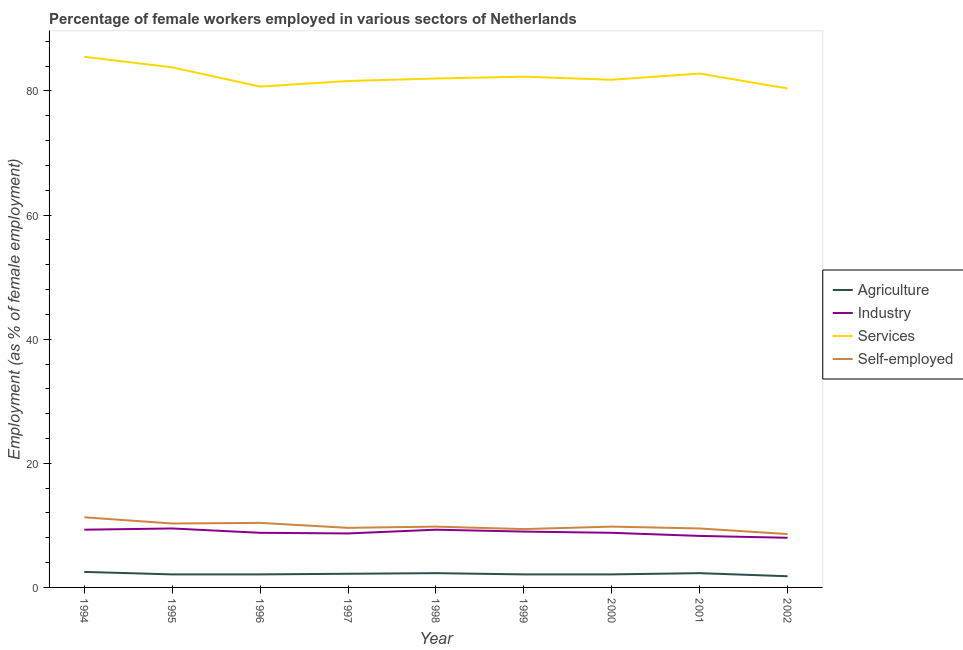How many different coloured lines are there?
Provide a succinct answer. 4. Does the line corresponding to percentage of self employed female workers intersect with the line corresponding to percentage of female workers in industry?
Keep it short and to the point. No. Is the number of lines equal to the number of legend labels?
Keep it short and to the point. Yes. What is the percentage of self employed female workers in 1994?
Your answer should be compact. 11.3. Across all years, what is the maximum percentage of female workers in services?
Make the answer very short. 85.5. Across all years, what is the minimum percentage of female workers in industry?
Ensure brevity in your answer.  8. In which year was the percentage of self employed female workers minimum?
Keep it short and to the point. 2002. What is the total percentage of female workers in agriculture in the graph?
Your answer should be compact. 19.5. What is the difference between the percentage of female workers in industry in 1996 and that in 1999?
Make the answer very short. -0.2. What is the difference between the percentage of self employed female workers in 2000 and the percentage of female workers in industry in 1995?
Give a very brief answer. 0.3. What is the average percentage of female workers in services per year?
Offer a terse response. 82.32. In the year 1996, what is the difference between the percentage of female workers in services and percentage of self employed female workers?
Provide a succinct answer. 70.3. In how many years, is the percentage of female workers in services greater than 64 %?
Provide a succinct answer. 9. What is the ratio of the percentage of female workers in services in 1998 to that in 2002?
Keep it short and to the point. 1.02. What is the difference between the highest and the second highest percentage of female workers in agriculture?
Your answer should be very brief. 0.2. What is the difference between the highest and the lowest percentage of female workers in services?
Your answer should be compact. 5.1. Is it the case that in every year, the sum of the percentage of self employed female workers and percentage of female workers in services is greater than the sum of percentage of female workers in agriculture and percentage of female workers in industry?
Your answer should be compact. Yes. How many years are there in the graph?
Make the answer very short. 9. What is the difference between two consecutive major ticks on the Y-axis?
Offer a terse response. 20. Are the values on the major ticks of Y-axis written in scientific E-notation?
Your response must be concise. No. Does the graph contain any zero values?
Ensure brevity in your answer.  No. Does the graph contain grids?
Your answer should be compact. No. Where does the legend appear in the graph?
Provide a succinct answer. Center right. How many legend labels are there?
Ensure brevity in your answer.  4. What is the title of the graph?
Give a very brief answer. Percentage of female workers employed in various sectors of Netherlands. What is the label or title of the X-axis?
Provide a succinct answer. Year. What is the label or title of the Y-axis?
Your answer should be compact. Employment (as % of female employment). What is the Employment (as % of female employment) of Agriculture in 1994?
Provide a short and direct response. 2.5. What is the Employment (as % of female employment) of Industry in 1994?
Your response must be concise. 9.3. What is the Employment (as % of female employment) of Services in 1994?
Offer a very short reply. 85.5. What is the Employment (as % of female employment) of Self-employed in 1994?
Provide a succinct answer. 11.3. What is the Employment (as % of female employment) of Agriculture in 1995?
Keep it short and to the point. 2.1. What is the Employment (as % of female employment) of Services in 1995?
Offer a very short reply. 83.8. What is the Employment (as % of female employment) of Self-employed in 1995?
Ensure brevity in your answer.  10.3. What is the Employment (as % of female employment) in Agriculture in 1996?
Offer a very short reply. 2.1. What is the Employment (as % of female employment) in Industry in 1996?
Offer a very short reply. 8.8. What is the Employment (as % of female employment) in Services in 1996?
Give a very brief answer. 80.7. What is the Employment (as % of female employment) in Self-employed in 1996?
Keep it short and to the point. 10.4. What is the Employment (as % of female employment) in Agriculture in 1997?
Keep it short and to the point. 2.2. What is the Employment (as % of female employment) of Industry in 1997?
Your answer should be compact. 8.7. What is the Employment (as % of female employment) in Services in 1997?
Provide a short and direct response. 81.6. What is the Employment (as % of female employment) in Self-employed in 1997?
Your response must be concise. 9.6. What is the Employment (as % of female employment) of Agriculture in 1998?
Offer a terse response. 2.3. What is the Employment (as % of female employment) in Industry in 1998?
Provide a short and direct response. 9.3. What is the Employment (as % of female employment) of Services in 1998?
Your answer should be very brief. 82. What is the Employment (as % of female employment) in Self-employed in 1998?
Offer a very short reply. 9.8. What is the Employment (as % of female employment) in Agriculture in 1999?
Make the answer very short. 2.1. What is the Employment (as % of female employment) of Services in 1999?
Make the answer very short. 82.3. What is the Employment (as % of female employment) in Self-employed in 1999?
Your answer should be compact. 9.4. What is the Employment (as % of female employment) in Agriculture in 2000?
Your response must be concise. 2.1. What is the Employment (as % of female employment) in Industry in 2000?
Provide a short and direct response. 8.8. What is the Employment (as % of female employment) in Services in 2000?
Give a very brief answer. 81.8. What is the Employment (as % of female employment) of Self-employed in 2000?
Provide a short and direct response. 9.8. What is the Employment (as % of female employment) in Agriculture in 2001?
Offer a very short reply. 2.3. What is the Employment (as % of female employment) in Industry in 2001?
Give a very brief answer. 8.3. What is the Employment (as % of female employment) of Services in 2001?
Make the answer very short. 82.8. What is the Employment (as % of female employment) in Self-employed in 2001?
Provide a succinct answer. 9.5. What is the Employment (as % of female employment) in Agriculture in 2002?
Ensure brevity in your answer.  1.8. What is the Employment (as % of female employment) in Industry in 2002?
Provide a short and direct response. 8. What is the Employment (as % of female employment) in Services in 2002?
Offer a terse response. 80.4. What is the Employment (as % of female employment) of Self-employed in 2002?
Provide a short and direct response. 8.6. Across all years, what is the maximum Employment (as % of female employment) in Industry?
Keep it short and to the point. 9.5. Across all years, what is the maximum Employment (as % of female employment) of Services?
Your answer should be compact. 85.5. Across all years, what is the maximum Employment (as % of female employment) in Self-employed?
Provide a short and direct response. 11.3. Across all years, what is the minimum Employment (as % of female employment) of Agriculture?
Make the answer very short. 1.8. Across all years, what is the minimum Employment (as % of female employment) of Services?
Your response must be concise. 80.4. Across all years, what is the minimum Employment (as % of female employment) in Self-employed?
Make the answer very short. 8.6. What is the total Employment (as % of female employment) in Industry in the graph?
Provide a short and direct response. 79.7. What is the total Employment (as % of female employment) of Services in the graph?
Keep it short and to the point. 740.9. What is the total Employment (as % of female employment) in Self-employed in the graph?
Your answer should be compact. 88.7. What is the difference between the Employment (as % of female employment) in Industry in 1994 and that in 1995?
Give a very brief answer. -0.2. What is the difference between the Employment (as % of female employment) of Services in 1994 and that in 1995?
Offer a very short reply. 1.7. What is the difference between the Employment (as % of female employment) of Services in 1994 and that in 1996?
Your answer should be very brief. 4.8. What is the difference between the Employment (as % of female employment) in Agriculture in 1994 and that in 1997?
Your answer should be compact. 0.3. What is the difference between the Employment (as % of female employment) in Industry in 1994 and that in 1997?
Your response must be concise. 0.6. What is the difference between the Employment (as % of female employment) of Self-employed in 1994 and that in 1997?
Provide a short and direct response. 1.7. What is the difference between the Employment (as % of female employment) of Industry in 1994 and that in 1998?
Offer a very short reply. 0. What is the difference between the Employment (as % of female employment) of Agriculture in 1994 and that in 1999?
Provide a short and direct response. 0.4. What is the difference between the Employment (as % of female employment) of Services in 1994 and that in 1999?
Offer a very short reply. 3.2. What is the difference between the Employment (as % of female employment) in Industry in 1994 and that in 2000?
Your response must be concise. 0.5. What is the difference between the Employment (as % of female employment) in Services in 1994 and that in 2000?
Your answer should be very brief. 3.7. What is the difference between the Employment (as % of female employment) of Agriculture in 1994 and that in 2001?
Keep it short and to the point. 0.2. What is the difference between the Employment (as % of female employment) in Services in 1994 and that in 2001?
Ensure brevity in your answer.  2.7. What is the difference between the Employment (as % of female employment) of Self-employed in 1994 and that in 2001?
Provide a short and direct response. 1.8. What is the difference between the Employment (as % of female employment) of Industry in 1994 and that in 2002?
Offer a terse response. 1.3. What is the difference between the Employment (as % of female employment) in Industry in 1995 and that in 1996?
Give a very brief answer. 0.7. What is the difference between the Employment (as % of female employment) in Industry in 1995 and that in 1997?
Make the answer very short. 0.8. What is the difference between the Employment (as % of female employment) in Services in 1995 and that in 1997?
Provide a short and direct response. 2.2. What is the difference between the Employment (as % of female employment) of Industry in 1995 and that in 1998?
Provide a succinct answer. 0.2. What is the difference between the Employment (as % of female employment) of Services in 1995 and that in 1998?
Keep it short and to the point. 1.8. What is the difference between the Employment (as % of female employment) of Self-employed in 1995 and that in 1998?
Provide a succinct answer. 0.5. What is the difference between the Employment (as % of female employment) in Agriculture in 1995 and that in 1999?
Ensure brevity in your answer.  0. What is the difference between the Employment (as % of female employment) of Industry in 1995 and that in 1999?
Make the answer very short. 0.5. What is the difference between the Employment (as % of female employment) in Industry in 1995 and that in 2000?
Ensure brevity in your answer.  0.7. What is the difference between the Employment (as % of female employment) of Industry in 1995 and that in 2001?
Ensure brevity in your answer.  1.2. What is the difference between the Employment (as % of female employment) in Services in 1995 and that in 2001?
Make the answer very short. 1. What is the difference between the Employment (as % of female employment) in Self-employed in 1995 and that in 2001?
Provide a short and direct response. 0.8. What is the difference between the Employment (as % of female employment) of Agriculture in 1995 and that in 2002?
Your answer should be compact. 0.3. What is the difference between the Employment (as % of female employment) in Services in 1995 and that in 2002?
Your response must be concise. 3.4. What is the difference between the Employment (as % of female employment) of Agriculture in 1996 and that in 1997?
Your answer should be compact. -0.1. What is the difference between the Employment (as % of female employment) in Industry in 1996 and that in 1997?
Offer a terse response. 0.1. What is the difference between the Employment (as % of female employment) of Services in 1996 and that in 1997?
Provide a succinct answer. -0.9. What is the difference between the Employment (as % of female employment) of Agriculture in 1996 and that in 1998?
Your answer should be very brief. -0.2. What is the difference between the Employment (as % of female employment) of Self-employed in 1996 and that in 1998?
Your response must be concise. 0.6. What is the difference between the Employment (as % of female employment) of Agriculture in 1996 and that in 1999?
Your answer should be compact. 0. What is the difference between the Employment (as % of female employment) of Industry in 1996 and that in 1999?
Provide a short and direct response. -0.2. What is the difference between the Employment (as % of female employment) in Services in 1996 and that in 1999?
Provide a short and direct response. -1.6. What is the difference between the Employment (as % of female employment) of Industry in 1996 and that in 2000?
Give a very brief answer. 0. What is the difference between the Employment (as % of female employment) in Services in 1996 and that in 2000?
Your response must be concise. -1.1. What is the difference between the Employment (as % of female employment) of Self-employed in 1996 and that in 2000?
Ensure brevity in your answer.  0.6. What is the difference between the Employment (as % of female employment) in Agriculture in 1996 and that in 2001?
Your response must be concise. -0.2. What is the difference between the Employment (as % of female employment) of Services in 1996 and that in 2001?
Ensure brevity in your answer.  -2.1. What is the difference between the Employment (as % of female employment) in Industry in 1996 and that in 2002?
Ensure brevity in your answer.  0.8. What is the difference between the Employment (as % of female employment) in Services in 1996 and that in 2002?
Your answer should be very brief. 0.3. What is the difference between the Employment (as % of female employment) in Self-employed in 1996 and that in 2002?
Make the answer very short. 1.8. What is the difference between the Employment (as % of female employment) in Industry in 1997 and that in 1998?
Offer a terse response. -0.6. What is the difference between the Employment (as % of female employment) of Services in 1997 and that in 1998?
Your answer should be compact. -0.4. What is the difference between the Employment (as % of female employment) in Self-employed in 1997 and that in 1998?
Your response must be concise. -0.2. What is the difference between the Employment (as % of female employment) in Industry in 1997 and that in 1999?
Your answer should be very brief. -0.3. What is the difference between the Employment (as % of female employment) of Self-employed in 1997 and that in 1999?
Offer a terse response. 0.2. What is the difference between the Employment (as % of female employment) of Industry in 1997 and that in 2000?
Provide a succinct answer. -0.1. What is the difference between the Employment (as % of female employment) in Services in 1997 and that in 2000?
Make the answer very short. -0.2. What is the difference between the Employment (as % of female employment) in Self-employed in 1997 and that in 2000?
Your answer should be compact. -0.2. What is the difference between the Employment (as % of female employment) in Agriculture in 1997 and that in 2001?
Make the answer very short. -0.1. What is the difference between the Employment (as % of female employment) in Industry in 1997 and that in 2001?
Offer a terse response. 0.4. What is the difference between the Employment (as % of female employment) in Services in 1997 and that in 2001?
Your answer should be very brief. -1.2. What is the difference between the Employment (as % of female employment) in Services in 1997 and that in 2002?
Your response must be concise. 1.2. What is the difference between the Employment (as % of female employment) of Agriculture in 1998 and that in 1999?
Make the answer very short. 0.2. What is the difference between the Employment (as % of female employment) in Industry in 1998 and that in 2000?
Keep it short and to the point. 0.5. What is the difference between the Employment (as % of female employment) of Services in 1998 and that in 2000?
Keep it short and to the point. 0.2. What is the difference between the Employment (as % of female employment) in Self-employed in 1998 and that in 2000?
Provide a succinct answer. 0. What is the difference between the Employment (as % of female employment) of Agriculture in 1998 and that in 2001?
Keep it short and to the point. 0. What is the difference between the Employment (as % of female employment) in Industry in 1998 and that in 2001?
Ensure brevity in your answer.  1. What is the difference between the Employment (as % of female employment) of Services in 1998 and that in 2001?
Make the answer very short. -0.8. What is the difference between the Employment (as % of female employment) of Self-employed in 1998 and that in 2001?
Offer a terse response. 0.3. What is the difference between the Employment (as % of female employment) of Agriculture in 1998 and that in 2002?
Your answer should be very brief. 0.5. What is the difference between the Employment (as % of female employment) of Industry in 1998 and that in 2002?
Make the answer very short. 1.3. What is the difference between the Employment (as % of female employment) of Self-employed in 1998 and that in 2002?
Your response must be concise. 1.2. What is the difference between the Employment (as % of female employment) of Agriculture in 1999 and that in 2001?
Make the answer very short. -0.2. What is the difference between the Employment (as % of female employment) in Services in 1999 and that in 2001?
Make the answer very short. -0.5. What is the difference between the Employment (as % of female employment) in Services in 1999 and that in 2002?
Provide a succinct answer. 1.9. What is the difference between the Employment (as % of female employment) of Self-employed in 1999 and that in 2002?
Offer a terse response. 0.8. What is the difference between the Employment (as % of female employment) of Agriculture in 2000 and that in 2001?
Make the answer very short. -0.2. What is the difference between the Employment (as % of female employment) of Services in 2000 and that in 2001?
Your answer should be compact. -1. What is the difference between the Employment (as % of female employment) in Agriculture in 2000 and that in 2002?
Your response must be concise. 0.3. What is the difference between the Employment (as % of female employment) in Agriculture in 2001 and that in 2002?
Your answer should be compact. 0.5. What is the difference between the Employment (as % of female employment) in Industry in 2001 and that in 2002?
Make the answer very short. 0.3. What is the difference between the Employment (as % of female employment) in Services in 2001 and that in 2002?
Keep it short and to the point. 2.4. What is the difference between the Employment (as % of female employment) of Self-employed in 2001 and that in 2002?
Keep it short and to the point. 0.9. What is the difference between the Employment (as % of female employment) in Agriculture in 1994 and the Employment (as % of female employment) in Industry in 1995?
Your answer should be compact. -7. What is the difference between the Employment (as % of female employment) in Agriculture in 1994 and the Employment (as % of female employment) in Services in 1995?
Give a very brief answer. -81.3. What is the difference between the Employment (as % of female employment) of Agriculture in 1994 and the Employment (as % of female employment) of Self-employed in 1995?
Ensure brevity in your answer.  -7.8. What is the difference between the Employment (as % of female employment) of Industry in 1994 and the Employment (as % of female employment) of Services in 1995?
Your answer should be very brief. -74.5. What is the difference between the Employment (as % of female employment) in Services in 1994 and the Employment (as % of female employment) in Self-employed in 1995?
Offer a terse response. 75.2. What is the difference between the Employment (as % of female employment) of Agriculture in 1994 and the Employment (as % of female employment) of Industry in 1996?
Your response must be concise. -6.3. What is the difference between the Employment (as % of female employment) of Agriculture in 1994 and the Employment (as % of female employment) of Services in 1996?
Give a very brief answer. -78.2. What is the difference between the Employment (as % of female employment) of Agriculture in 1994 and the Employment (as % of female employment) of Self-employed in 1996?
Provide a succinct answer. -7.9. What is the difference between the Employment (as % of female employment) in Industry in 1994 and the Employment (as % of female employment) in Services in 1996?
Give a very brief answer. -71.4. What is the difference between the Employment (as % of female employment) in Industry in 1994 and the Employment (as % of female employment) in Self-employed in 1996?
Your response must be concise. -1.1. What is the difference between the Employment (as % of female employment) in Services in 1994 and the Employment (as % of female employment) in Self-employed in 1996?
Your answer should be very brief. 75.1. What is the difference between the Employment (as % of female employment) in Agriculture in 1994 and the Employment (as % of female employment) in Services in 1997?
Keep it short and to the point. -79.1. What is the difference between the Employment (as % of female employment) in Industry in 1994 and the Employment (as % of female employment) in Services in 1997?
Your response must be concise. -72.3. What is the difference between the Employment (as % of female employment) in Industry in 1994 and the Employment (as % of female employment) in Self-employed in 1997?
Ensure brevity in your answer.  -0.3. What is the difference between the Employment (as % of female employment) of Services in 1994 and the Employment (as % of female employment) of Self-employed in 1997?
Provide a succinct answer. 75.9. What is the difference between the Employment (as % of female employment) in Agriculture in 1994 and the Employment (as % of female employment) in Industry in 1998?
Provide a short and direct response. -6.8. What is the difference between the Employment (as % of female employment) of Agriculture in 1994 and the Employment (as % of female employment) of Services in 1998?
Offer a very short reply. -79.5. What is the difference between the Employment (as % of female employment) of Industry in 1994 and the Employment (as % of female employment) of Services in 1998?
Offer a terse response. -72.7. What is the difference between the Employment (as % of female employment) of Services in 1994 and the Employment (as % of female employment) of Self-employed in 1998?
Provide a succinct answer. 75.7. What is the difference between the Employment (as % of female employment) in Agriculture in 1994 and the Employment (as % of female employment) in Industry in 1999?
Ensure brevity in your answer.  -6.5. What is the difference between the Employment (as % of female employment) of Agriculture in 1994 and the Employment (as % of female employment) of Services in 1999?
Provide a succinct answer. -79.8. What is the difference between the Employment (as % of female employment) of Agriculture in 1994 and the Employment (as % of female employment) of Self-employed in 1999?
Offer a terse response. -6.9. What is the difference between the Employment (as % of female employment) of Industry in 1994 and the Employment (as % of female employment) of Services in 1999?
Keep it short and to the point. -73. What is the difference between the Employment (as % of female employment) in Services in 1994 and the Employment (as % of female employment) in Self-employed in 1999?
Make the answer very short. 76.1. What is the difference between the Employment (as % of female employment) in Agriculture in 1994 and the Employment (as % of female employment) in Industry in 2000?
Offer a terse response. -6.3. What is the difference between the Employment (as % of female employment) in Agriculture in 1994 and the Employment (as % of female employment) in Services in 2000?
Keep it short and to the point. -79.3. What is the difference between the Employment (as % of female employment) of Agriculture in 1994 and the Employment (as % of female employment) of Self-employed in 2000?
Your answer should be compact. -7.3. What is the difference between the Employment (as % of female employment) in Industry in 1994 and the Employment (as % of female employment) in Services in 2000?
Your answer should be compact. -72.5. What is the difference between the Employment (as % of female employment) of Industry in 1994 and the Employment (as % of female employment) of Self-employed in 2000?
Keep it short and to the point. -0.5. What is the difference between the Employment (as % of female employment) in Services in 1994 and the Employment (as % of female employment) in Self-employed in 2000?
Keep it short and to the point. 75.7. What is the difference between the Employment (as % of female employment) of Agriculture in 1994 and the Employment (as % of female employment) of Industry in 2001?
Your answer should be very brief. -5.8. What is the difference between the Employment (as % of female employment) of Agriculture in 1994 and the Employment (as % of female employment) of Services in 2001?
Provide a succinct answer. -80.3. What is the difference between the Employment (as % of female employment) of Agriculture in 1994 and the Employment (as % of female employment) of Self-employed in 2001?
Provide a short and direct response. -7. What is the difference between the Employment (as % of female employment) of Industry in 1994 and the Employment (as % of female employment) of Services in 2001?
Your response must be concise. -73.5. What is the difference between the Employment (as % of female employment) in Industry in 1994 and the Employment (as % of female employment) in Self-employed in 2001?
Give a very brief answer. -0.2. What is the difference between the Employment (as % of female employment) of Agriculture in 1994 and the Employment (as % of female employment) of Services in 2002?
Offer a terse response. -77.9. What is the difference between the Employment (as % of female employment) in Agriculture in 1994 and the Employment (as % of female employment) in Self-employed in 2002?
Provide a short and direct response. -6.1. What is the difference between the Employment (as % of female employment) of Industry in 1994 and the Employment (as % of female employment) of Services in 2002?
Provide a short and direct response. -71.1. What is the difference between the Employment (as % of female employment) in Services in 1994 and the Employment (as % of female employment) in Self-employed in 2002?
Your answer should be very brief. 76.9. What is the difference between the Employment (as % of female employment) of Agriculture in 1995 and the Employment (as % of female employment) of Services in 1996?
Offer a terse response. -78.6. What is the difference between the Employment (as % of female employment) in Industry in 1995 and the Employment (as % of female employment) in Services in 1996?
Your answer should be very brief. -71.2. What is the difference between the Employment (as % of female employment) in Industry in 1995 and the Employment (as % of female employment) in Self-employed in 1996?
Give a very brief answer. -0.9. What is the difference between the Employment (as % of female employment) in Services in 1995 and the Employment (as % of female employment) in Self-employed in 1996?
Ensure brevity in your answer.  73.4. What is the difference between the Employment (as % of female employment) of Agriculture in 1995 and the Employment (as % of female employment) of Services in 1997?
Your answer should be very brief. -79.5. What is the difference between the Employment (as % of female employment) of Agriculture in 1995 and the Employment (as % of female employment) of Self-employed in 1997?
Ensure brevity in your answer.  -7.5. What is the difference between the Employment (as % of female employment) of Industry in 1995 and the Employment (as % of female employment) of Services in 1997?
Give a very brief answer. -72.1. What is the difference between the Employment (as % of female employment) of Industry in 1995 and the Employment (as % of female employment) of Self-employed in 1997?
Offer a terse response. -0.1. What is the difference between the Employment (as % of female employment) of Services in 1995 and the Employment (as % of female employment) of Self-employed in 1997?
Provide a short and direct response. 74.2. What is the difference between the Employment (as % of female employment) in Agriculture in 1995 and the Employment (as % of female employment) in Industry in 1998?
Offer a terse response. -7.2. What is the difference between the Employment (as % of female employment) in Agriculture in 1995 and the Employment (as % of female employment) in Services in 1998?
Your answer should be compact. -79.9. What is the difference between the Employment (as % of female employment) of Agriculture in 1995 and the Employment (as % of female employment) of Self-employed in 1998?
Give a very brief answer. -7.7. What is the difference between the Employment (as % of female employment) in Industry in 1995 and the Employment (as % of female employment) in Services in 1998?
Make the answer very short. -72.5. What is the difference between the Employment (as % of female employment) in Industry in 1995 and the Employment (as % of female employment) in Self-employed in 1998?
Offer a terse response. -0.3. What is the difference between the Employment (as % of female employment) in Services in 1995 and the Employment (as % of female employment) in Self-employed in 1998?
Offer a very short reply. 74. What is the difference between the Employment (as % of female employment) of Agriculture in 1995 and the Employment (as % of female employment) of Services in 1999?
Offer a very short reply. -80.2. What is the difference between the Employment (as % of female employment) of Agriculture in 1995 and the Employment (as % of female employment) of Self-employed in 1999?
Provide a succinct answer. -7.3. What is the difference between the Employment (as % of female employment) of Industry in 1995 and the Employment (as % of female employment) of Services in 1999?
Keep it short and to the point. -72.8. What is the difference between the Employment (as % of female employment) of Services in 1995 and the Employment (as % of female employment) of Self-employed in 1999?
Your answer should be compact. 74.4. What is the difference between the Employment (as % of female employment) in Agriculture in 1995 and the Employment (as % of female employment) in Services in 2000?
Your response must be concise. -79.7. What is the difference between the Employment (as % of female employment) in Industry in 1995 and the Employment (as % of female employment) in Services in 2000?
Give a very brief answer. -72.3. What is the difference between the Employment (as % of female employment) of Agriculture in 1995 and the Employment (as % of female employment) of Industry in 2001?
Provide a succinct answer. -6.2. What is the difference between the Employment (as % of female employment) in Agriculture in 1995 and the Employment (as % of female employment) in Services in 2001?
Make the answer very short. -80.7. What is the difference between the Employment (as % of female employment) of Industry in 1995 and the Employment (as % of female employment) of Services in 2001?
Your answer should be compact. -73.3. What is the difference between the Employment (as % of female employment) of Industry in 1995 and the Employment (as % of female employment) of Self-employed in 2001?
Keep it short and to the point. 0. What is the difference between the Employment (as % of female employment) of Services in 1995 and the Employment (as % of female employment) of Self-employed in 2001?
Offer a terse response. 74.3. What is the difference between the Employment (as % of female employment) of Agriculture in 1995 and the Employment (as % of female employment) of Services in 2002?
Your answer should be very brief. -78.3. What is the difference between the Employment (as % of female employment) in Industry in 1995 and the Employment (as % of female employment) in Services in 2002?
Offer a terse response. -70.9. What is the difference between the Employment (as % of female employment) of Services in 1995 and the Employment (as % of female employment) of Self-employed in 2002?
Offer a terse response. 75.2. What is the difference between the Employment (as % of female employment) in Agriculture in 1996 and the Employment (as % of female employment) in Services in 1997?
Give a very brief answer. -79.5. What is the difference between the Employment (as % of female employment) in Industry in 1996 and the Employment (as % of female employment) in Services in 1997?
Make the answer very short. -72.8. What is the difference between the Employment (as % of female employment) of Services in 1996 and the Employment (as % of female employment) of Self-employed in 1997?
Make the answer very short. 71.1. What is the difference between the Employment (as % of female employment) of Agriculture in 1996 and the Employment (as % of female employment) of Industry in 1998?
Keep it short and to the point. -7.2. What is the difference between the Employment (as % of female employment) in Agriculture in 1996 and the Employment (as % of female employment) in Services in 1998?
Make the answer very short. -79.9. What is the difference between the Employment (as % of female employment) in Industry in 1996 and the Employment (as % of female employment) in Services in 1998?
Keep it short and to the point. -73.2. What is the difference between the Employment (as % of female employment) of Industry in 1996 and the Employment (as % of female employment) of Self-employed in 1998?
Give a very brief answer. -1. What is the difference between the Employment (as % of female employment) of Services in 1996 and the Employment (as % of female employment) of Self-employed in 1998?
Your answer should be very brief. 70.9. What is the difference between the Employment (as % of female employment) of Agriculture in 1996 and the Employment (as % of female employment) of Industry in 1999?
Make the answer very short. -6.9. What is the difference between the Employment (as % of female employment) of Agriculture in 1996 and the Employment (as % of female employment) of Services in 1999?
Provide a succinct answer. -80.2. What is the difference between the Employment (as % of female employment) in Industry in 1996 and the Employment (as % of female employment) in Services in 1999?
Offer a terse response. -73.5. What is the difference between the Employment (as % of female employment) in Industry in 1996 and the Employment (as % of female employment) in Self-employed in 1999?
Keep it short and to the point. -0.6. What is the difference between the Employment (as % of female employment) in Services in 1996 and the Employment (as % of female employment) in Self-employed in 1999?
Provide a succinct answer. 71.3. What is the difference between the Employment (as % of female employment) of Agriculture in 1996 and the Employment (as % of female employment) of Services in 2000?
Your response must be concise. -79.7. What is the difference between the Employment (as % of female employment) of Industry in 1996 and the Employment (as % of female employment) of Services in 2000?
Keep it short and to the point. -73. What is the difference between the Employment (as % of female employment) of Services in 1996 and the Employment (as % of female employment) of Self-employed in 2000?
Make the answer very short. 70.9. What is the difference between the Employment (as % of female employment) in Agriculture in 1996 and the Employment (as % of female employment) in Services in 2001?
Give a very brief answer. -80.7. What is the difference between the Employment (as % of female employment) in Agriculture in 1996 and the Employment (as % of female employment) in Self-employed in 2001?
Provide a short and direct response. -7.4. What is the difference between the Employment (as % of female employment) in Industry in 1996 and the Employment (as % of female employment) in Services in 2001?
Ensure brevity in your answer.  -74. What is the difference between the Employment (as % of female employment) in Industry in 1996 and the Employment (as % of female employment) in Self-employed in 2001?
Your answer should be compact. -0.7. What is the difference between the Employment (as % of female employment) in Services in 1996 and the Employment (as % of female employment) in Self-employed in 2001?
Offer a terse response. 71.2. What is the difference between the Employment (as % of female employment) in Agriculture in 1996 and the Employment (as % of female employment) in Industry in 2002?
Give a very brief answer. -5.9. What is the difference between the Employment (as % of female employment) in Agriculture in 1996 and the Employment (as % of female employment) in Services in 2002?
Keep it short and to the point. -78.3. What is the difference between the Employment (as % of female employment) of Agriculture in 1996 and the Employment (as % of female employment) of Self-employed in 2002?
Provide a short and direct response. -6.5. What is the difference between the Employment (as % of female employment) in Industry in 1996 and the Employment (as % of female employment) in Services in 2002?
Offer a terse response. -71.6. What is the difference between the Employment (as % of female employment) of Industry in 1996 and the Employment (as % of female employment) of Self-employed in 2002?
Offer a terse response. 0.2. What is the difference between the Employment (as % of female employment) in Services in 1996 and the Employment (as % of female employment) in Self-employed in 2002?
Offer a very short reply. 72.1. What is the difference between the Employment (as % of female employment) of Agriculture in 1997 and the Employment (as % of female employment) of Services in 1998?
Your response must be concise. -79.8. What is the difference between the Employment (as % of female employment) in Industry in 1997 and the Employment (as % of female employment) in Services in 1998?
Offer a terse response. -73.3. What is the difference between the Employment (as % of female employment) of Industry in 1997 and the Employment (as % of female employment) of Self-employed in 1998?
Keep it short and to the point. -1.1. What is the difference between the Employment (as % of female employment) of Services in 1997 and the Employment (as % of female employment) of Self-employed in 1998?
Your answer should be compact. 71.8. What is the difference between the Employment (as % of female employment) of Agriculture in 1997 and the Employment (as % of female employment) of Industry in 1999?
Provide a succinct answer. -6.8. What is the difference between the Employment (as % of female employment) of Agriculture in 1997 and the Employment (as % of female employment) of Services in 1999?
Your answer should be very brief. -80.1. What is the difference between the Employment (as % of female employment) in Industry in 1997 and the Employment (as % of female employment) in Services in 1999?
Your answer should be very brief. -73.6. What is the difference between the Employment (as % of female employment) in Industry in 1997 and the Employment (as % of female employment) in Self-employed in 1999?
Your answer should be compact. -0.7. What is the difference between the Employment (as % of female employment) in Services in 1997 and the Employment (as % of female employment) in Self-employed in 1999?
Your response must be concise. 72.2. What is the difference between the Employment (as % of female employment) of Agriculture in 1997 and the Employment (as % of female employment) of Industry in 2000?
Offer a very short reply. -6.6. What is the difference between the Employment (as % of female employment) of Agriculture in 1997 and the Employment (as % of female employment) of Services in 2000?
Your response must be concise. -79.6. What is the difference between the Employment (as % of female employment) in Industry in 1997 and the Employment (as % of female employment) in Services in 2000?
Offer a terse response. -73.1. What is the difference between the Employment (as % of female employment) of Services in 1997 and the Employment (as % of female employment) of Self-employed in 2000?
Offer a terse response. 71.8. What is the difference between the Employment (as % of female employment) in Agriculture in 1997 and the Employment (as % of female employment) in Industry in 2001?
Offer a terse response. -6.1. What is the difference between the Employment (as % of female employment) of Agriculture in 1997 and the Employment (as % of female employment) of Services in 2001?
Give a very brief answer. -80.6. What is the difference between the Employment (as % of female employment) in Industry in 1997 and the Employment (as % of female employment) in Services in 2001?
Provide a succinct answer. -74.1. What is the difference between the Employment (as % of female employment) in Services in 1997 and the Employment (as % of female employment) in Self-employed in 2001?
Make the answer very short. 72.1. What is the difference between the Employment (as % of female employment) of Agriculture in 1997 and the Employment (as % of female employment) of Industry in 2002?
Your response must be concise. -5.8. What is the difference between the Employment (as % of female employment) of Agriculture in 1997 and the Employment (as % of female employment) of Services in 2002?
Keep it short and to the point. -78.2. What is the difference between the Employment (as % of female employment) of Agriculture in 1997 and the Employment (as % of female employment) of Self-employed in 2002?
Keep it short and to the point. -6.4. What is the difference between the Employment (as % of female employment) in Industry in 1997 and the Employment (as % of female employment) in Services in 2002?
Keep it short and to the point. -71.7. What is the difference between the Employment (as % of female employment) of Industry in 1997 and the Employment (as % of female employment) of Self-employed in 2002?
Your response must be concise. 0.1. What is the difference between the Employment (as % of female employment) of Agriculture in 1998 and the Employment (as % of female employment) of Industry in 1999?
Offer a terse response. -6.7. What is the difference between the Employment (as % of female employment) in Agriculture in 1998 and the Employment (as % of female employment) in Services in 1999?
Ensure brevity in your answer.  -80. What is the difference between the Employment (as % of female employment) in Agriculture in 1998 and the Employment (as % of female employment) in Self-employed in 1999?
Provide a succinct answer. -7.1. What is the difference between the Employment (as % of female employment) in Industry in 1998 and the Employment (as % of female employment) in Services in 1999?
Keep it short and to the point. -73. What is the difference between the Employment (as % of female employment) of Industry in 1998 and the Employment (as % of female employment) of Self-employed in 1999?
Provide a succinct answer. -0.1. What is the difference between the Employment (as % of female employment) of Services in 1998 and the Employment (as % of female employment) of Self-employed in 1999?
Give a very brief answer. 72.6. What is the difference between the Employment (as % of female employment) of Agriculture in 1998 and the Employment (as % of female employment) of Industry in 2000?
Your answer should be compact. -6.5. What is the difference between the Employment (as % of female employment) of Agriculture in 1998 and the Employment (as % of female employment) of Services in 2000?
Keep it short and to the point. -79.5. What is the difference between the Employment (as % of female employment) of Agriculture in 1998 and the Employment (as % of female employment) of Self-employed in 2000?
Make the answer very short. -7.5. What is the difference between the Employment (as % of female employment) of Industry in 1998 and the Employment (as % of female employment) of Services in 2000?
Keep it short and to the point. -72.5. What is the difference between the Employment (as % of female employment) in Services in 1998 and the Employment (as % of female employment) in Self-employed in 2000?
Offer a very short reply. 72.2. What is the difference between the Employment (as % of female employment) in Agriculture in 1998 and the Employment (as % of female employment) in Industry in 2001?
Ensure brevity in your answer.  -6. What is the difference between the Employment (as % of female employment) in Agriculture in 1998 and the Employment (as % of female employment) in Services in 2001?
Give a very brief answer. -80.5. What is the difference between the Employment (as % of female employment) of Industry in 1998 and the Employment (as % of female employment) of Services in 2001?
Keep it short and to the point. -73.5. What is the difference between the Employment (as % of female employment) in Services in 1998 and the Employment (as % of female employment) in Self-employed in 2001?
Your response must be concise. 72.5. What is the difference between the Employment (as % of female employment) of Agriculture in 1998 and the Employment (as % of female employment) of Services in 2002?
Offer a terse response. -78.1. What is the difference between the Employment (as % of female employment) in Agriculture in 1998 and the Employment (as % of female employment) in Self-employed in 2002?
Your response must be concise. -6.3. What is the difference between the Employment (as % of female employment) of Industry in 1998 and the Employment (as % of female employment) of Services in 2002?
Your response must be concise. -71.1. What is the difference between the Employment (as % of female employment) of Industry in 1998 and the Employment (as % of female employment) of Self-employed in 2002?
Your answer should be compact. 0.7. What is the difference between the Employment (as % of female employment) of Services in 1998 and the Employment (as % of female employment) of Self-employed in 2002?
Provide a short and direct response. 73.4. What is the difference between the Employment (as % of female employment) of Agriculture in 1999 and the Employment (as % of female employment) of Services in 2000?
Offer a terse response. -79.7. What is the difference between the Employment (as % of female employment) in Agriculture in 1999 and the Employment (as % of female employment) in Self-employed in 2000?
Provide a short and direct response. -7.7. What is the difference between the Employment (as % of female employment) of Industry in 1999 and the Employment (as % of female employment) of Services in 2000?
Your answer should be compact. -72.8. What is the difference between the Employment (as % of female employment) in Services in 1999 and the Employment (as % of female employment) in Self-employed in 2000?
Keep it short and to the point. 72.5. What is the difference between the Employment (as % of female employment) of Agriculture in 1999 and the Employment (as % of female employment) of Services in 2001?
Your answer should be very brief. -80.7. What is the difference between the Employment (as % of female employment) of Industry in 1999 and the Employment (as % of female employment) of Services in 2001?
Provide a short and direct response. -73.8. What is the difference between the Employment (as % of female employment) in Services in 1999 and the Employment (as % of female employment) in Self-employed in 2001?
Your answer should be very brief. 72.8. What is the difference between the Employment (as % of female employment) in Agriculture in 1999 and the Employment (as % of female employment) in Industry in 2002?
Your response must be concise. -5.9. What is the difference between the Employment (as % of female employment) in Agriculture in 1999 and the Employment (as % of female employment) in Services in 2002?
Your answer should be very brief. -78.3. What is the difference between the Employment (as % of female employment) of Agriculture in 1999 and the Employment (as % of female employment) of Self-employed in 2002?
Offer a terse response. -6.5. What is the difference between the Employment (as % of female employment) in Industry in 1999 and the Employment (as % of female employment) in Services in 2002?
Offer a very short reply. -71.4. What is the difference between the Employment (as % of female employment) in Services in 1999 and the Employment (as % of female employment) in Self-employed in 2002?
Your response must be concise. 73.7. What is the difference between the Employment (as % of female employment) of Agriculture in 2000 and the Employment (as % of female employment) of Industry in 2001?
Offer a very short reply. -6.2. What is the difference between the Employment (as % of female employment) of Agriculture in 2000 and the Employment (as % of female employment) of Services in 2001?
Ensure brevity in your answer.  -80.7. What is the difference between the Employment (as % of female employment) in Agriculture in 2000 and the Employment (as % of female employment) in Self-employed in 2001?
Your answer should be compact. -7.4. What is the difference between the Employment (as % of female employment) of Industry in 2000 and the Employment (as % of female employment) of Services in 2001?
Ensure brevity in your answer.  -74. What is the difference between the Employment (as % of female employment) in Services in 2000 and the Employment (as % of female employment) in Self-employed in 2001?
Your answer should be compact. 72.3. What is the difference between the Employment (as % of female employment) of Agriculture in 2000 and the Employment (as % of female employment) of Services in 2002?
Your answer should be very brief. -78.3. What is the difference between the Employment (as % of female employment) in Industry in 2000 and the Employment (as % of female employment) in Services in 2002?
Ensure brevity in your answer.  -71.6. What is the difference between the Employment (as % of female employment) in Services in 2000 and the Employment (as % of female employment) in Self-employed in 2002?
Give a very brief answer. 73.2. What is the difference between the Employment (as % of female employment) in Agriculture in 2001 and the Employment (as % of female employment) in Industry in 2002?
Offer a very short reply. -5.7. What is the difference between the Employment (as % of female employment) of Agriculture in 2001 and the Employment (as % of female employment) of Services in 2002?
Ensure brevity in your answer.  -78.1. What is the difference between the Employment (as % of female employment) in Industry in 2001 and the Employment (as % of female employment) in Services in 2002?
Give a very brief answer. -72.1. What is the difference between the Employment (as % of female employment) of Services in 2001 and the Employment (as % of female employment) of Self-employed in 2002?
Offer a very short reply. 74.2. What is the average Employment (as % of female employment) of Agriculture per year?
Give a very brief answer. 2.17. What is the average Employment (as % of female employment) in Industry per year?
Your response must be concise. 8.86. What is the average Employment (as % of female employment) in Services per year?
Ensure brevity in your answer.  82.32. What is the average Employment (as % of female employment) of Self-employed per year?
Make the answer very short. 9.86. In the year 1994, what is the difference between the Employment (as % of female employment) in Agriculture and Employment (as % of female employment) in Industry?
Provide a succinct answer. -6.8. In the year 1994, what is the difference between the Employment (as % of female employment) in Agriculture and Employment (as % of female employment) in Services?
Offer a terse response. -83. In the year 1994, what is the difference between the Employment (as % of female employment) in Industry and Employment (as % of female employment) in Services?
Provide a short and direct response. -76.2. In the year 1994, what is the difference between the Employment (as % of female employment) of Services and Employment (as % of female employment) of Self-employed?
Your answer should be compact. 74.2. In the year 1995, what is the difference between the Employment (as % of female employment) in Agriculture and Employment (as % of female employment) in Services?
Your answer should be compact. -81.7. In the year 1995, what is the difference between the Employment (as % of female employment) of Agriculture and Employment (as % of female employment) of Self-employed?
Offer a terse response. -8.2. In the year 1995, what is the difference between the Employment (as % of female employment) in Industry and Employment (as % of female employment) in Services?
Ensure brevity in your answer.  -74.3. In the year 1995, what is the difference between the Employment (as % of female employment) of Services and Employment (as % of female employment) of Self-employed?
Your answer should be very brief. 73.5. In the year 1996, what is the difference between the Employment (as % of female employment) in Agriculture and Employment (as % of female employment) in Services?
Your answer should be compact. -78.6. In the year 1996, what is the difference between the Employment (as % of female employment) in Industry and Employment (as % of female employment) in Services?
Your answer should be compact. -71.9. In the year 1996, what is the difference between the Employment (as % of female employment) in Industry and Employment (as % of female employment) in Self-employed?
Your answer should be very brief. -1.6. In the year 1996, what is the difference between the Employment (as % of female employment) in Services and Employment (as % of female employment) in Self-employed?
Your answer should be compact. 70.3. In the year 1997, what is the difference between the Employment (as % of female employment) of Agriculture and Employment (as % of female employment) of Services?
Offer a very short reply. -79.4. In the year 1997, what is the difference between the Employment (as % of female employment) of Agriculture and Employment (as % of female employment) of Self-employed?
Make the answer very short. -7.4. In the year 1997, what is the difference between the Employment (as % of female employment) of Industry and Employment (as % of female employment) of Services?
Your response must be concise. -72.9. In the year 1997, what is the difference between the Employment (as % of female employment) in Services and Employment (as % of female employment) in Self-employed?
Provide a short and direct response. 72. In the year 1998, what is the difference between the Employment (as % of female employment) of Agriculture and Employment (as % of female employment) of Services?
Offer a terse response. -79.7. In the year 1998, what is the difference between the Employment (as % of female employment) in Agriculture and Employment (as % of female employment) in Self-employed?
Provide a short and direct response. -7.5. In the year 1998, what is the difference between the Employment (as % of female employment) in Industry and Employment (as % of female employment) in Services?
Your answer should be compact. -72.7. In the year 1998, what is the difference between the Employment (as % of female employment) of Services and Employment (as % of female employment) of Self-employed?
Keep it short and to the point. 72.2. In the year 1999, what is the difference between the Employment (as % of female employment) of Agriculture and Employment (as % of female employment) of Services?
Offer a terse response. -80.2. In the year 1999, what is the difference between the Employment (as % of female employment) of Agriculture and Employment (as % of female employment) of Self-employed?
Keep it short and to the point. -7.3. In the year 1999, what is the difference between the Employment (as % of female employment) of Industry and Employment (as % of female employment) of Services?
Keep it short and to the point. -73.3. In the year 1999, what is the difference between the Employment (as % of female employment) in Industry and Employment (as % of female employment) in Self-employed?
Your answer should be very brief. -0.4. In the year 1999, what is the difference between the Employment (as % of female employment) of Services and Employment (as % of female employment) of Self-employed?
Ensure brevity in your answer.  72.9. In the year 2000, what is the difference between the Employment (as % of female employment) of Agriculture and Employment (as % of female employment) of Services?
Ensure brevity in your answer.  -79.7. In the year 2000, what is the difference between the Employment (as % of female employment) in Agriculture and Employment (as % of female employment) in Self-employed?
Make the answer very short. -7.7. In the year 2000, what is the difference between the Employment (as % of female employment) of Industry and Employment (as % of female employment) of Services?
Your answer should be very brief. -73. In the year 2000, what is the difference between the Employment (as % of female employment) in Industry and Employment (as % of female employment) in Self-employed?
Your answer should be compact. -1. In the year 2001, what is the difference between the Employment (as % of female employment) of Agriculture and Employment (as % of female employment) of Services?
Offer a very short reply. -80.5. In the year 2001, what is the difference between the Employment (as % of female employment) in Industry and Employment (as % of female employment) in Services?
Your answer should be compact. -74.5. In the year 2001, what is the difference between the Employment (as % of female employment) of Industry and Employment (as % of female employment) of Self-employed?
Offer a terse response. -1.2. In the year 2001, what is the difference between the Employment (as % of female employment) in Services and Employment (as % of female employment) in Self-employed?
Give a very brief answer. 73.3. In the year 2002, what is the difference between the Employment (as % of female employment) in Agriculture and Employment (as % of female employment) in Industry?
Provide a short and direct response. -6.2. In the year 2002, what is the difference between the Employment (as % of female employment) in Agriculture and Employment (as % of female employment) in Services?
Offer a terse response. -78.6. In the year 2002, what is the difference between the Employment (as % of female employment) of Industry and Employment (as % of female employment) of Services?
Provide a short and direct response. -72.4. In the year 2002, what is the difference between the Employment (as % of female employment) of Industry and Employment (as % of female employment) of Self-employed?
Your answer should be compact. -0.6. In the year 2002, what is the difference between the Employment (as % of female employment) of Services and Employment (as % of female employment) of Self-employed?
Keep it short and to the point. 71.8. What is the ratio of the Employment (as % of female employment) of Agriculture in 1994 to that in 1995?
Your response must be concise. 1.19. What is the ratio of the Employment (as % of female employment) of Industry in 1994 to that in 1995?
Offer a terse response. 0.98. What is the ratio of the Employment (as % of female employment) of Services in 1994 to that in 1995?
Make the answer very short. 1.02. What is the ratio of the Employment (as % of female employment) in Self-employed in 1994 to that in 1995?
Keep it short and to the point. 1.1. What is the ratio of the Employment (as % of female employment) in Agriculture in 1994 to that in 1996?
Provide a short and direct response. 1.19. What is the ratio of the Employment (as % of female employment) of Industry in 1994 to that in 1996?
Ensure brevity in your answer.  1.06. What is the ratio of the Employment (as % of female employment) of Services in 1994 to that in 1996?
Ensure brevity in your answer.  1.06. What is the ratio of the Employment (as % of female employment) in Self-employed in 1994 to that in 1996?
Keep it short and to the point. 1.09. What is the ratio of the Employment (as % of female employment) of Agriculture in 1994 to that in 1997?
Your answer should be compact. 1.14. What is the ratio of the Employment (as % of female employment) of Industry in 1994 to that in 1997?
Keep it short and to the point. 1.07. What is the ratio of the Employment (as % of female employment) in Services in 1994 to that in 1997?
Ensure brevity in your answer.  1.05. What is the ratio of the Employment (as % of female employment) of Self-employed in 1994 to that in 1997?
Provide a short and direct response. 1.18. What is the ratio of the Employment (as % of female employment) of Agriculture in 1994 to that in 1998?
Give a very brief answer. 1.09. What is the ratio of the Employment (as % of female employment) of Industry in 1994 to that in 1998?
Ensure brevity in your answer.  1. What is the ratio of the Employment (as % of female employment) in Services in 1994 to that in 1998?
Provide a short and direct response. 1.04. What is the ratio of the Employment (as % of female employment) of Self-employed in 1994 to that in 1998?
Provide a short and direct response. 1.15. What is the ratio of the Employment (as % of female employment) in Agriculture in 1994 to that in 1999?
Offer a very short reply. 1.19. What is the ratio of the Employment (as % of female employment) in Services in 1994 to that in 1999?
Keep it short and to the point. 1.04. What is the ratio of the Employment (as % of female employment) in Self-employed in 1994 to that in 1999?
Offer a very short reply. 1.2. What is the ratio of the Employment (as % of female employment) of Agriculture in 1994 to that in 2000?
Keep it short and to the point. 1.19. What is the ratio of the Employment (as % of female employment) in Industry in 1994 to that in 2000?
Your answer should be very brief. 1.06. What is the ratio of the Employment (as % of female employment) in Services in 1994 to that in 2000?
Your answer should be very brief. 1.05. What is the ratio of the Employment (as % of female employment) in Self-employed in 1994 to that in 2000?
Your answer should be very brief. 1.15. What is the ratio of the Employment (as % of female employment) of Agriculture in 1994 to that in 2001?
Your answer should be compact. 1.09. What is the ratio of the Employment (as % of female employment) in Industry in 1994 to that in 2001?
Your answer should be compact. 1.12. What is the ratio of the Employment (as % of female employment) in Services in 1994 to that in 2001?
Offer a very short reply. 1.03. What is the ratio of the Employment (as % of female employment) in Self-employed in 1994 to that in 2001?
Keep it short and to the point. 1.19. What is the ratio of the Employment (as % of female employment) in Agriculture in 1994 to that in 2002?
Give a very brief answer. 1.39. What is the ratio of the Employment (as % of female employment) in Industry in 1994 to that in 2002?
Make the answer very short. 1.16. What is the ratio of the Employment (as % of female employment) in Services in 1994 to that in 2002?
Make the answer very short. 1.06. What is the ratio of the Employment (as % of female employment) in Self-employed in 1994 to that in 2002?
Your answer should be compact. 1.31. What is the ratio of the Employment (as % of female employment) in Industry in 1995 to that in 1996?
Give a very brief answer. 1.08. What is the ratio of the Employment (as % of female employment) in Services in 1995 to that in 1996?
Your answer should be very brief. 1.04. What is the ratio of the Employment (as % of female employment) in Self-employed in 1995 to that in 1996?
Your response must be concise. 0.99. What is the ratio of the Employment (as % of female employment) of Agriculture in 1995 to that in 1997?
Make the answer very short. 0.95. What is the ratio of the Employment (as % of female employment) of Industry in 1995 to that in 1997?
Your answer should be compact. 1.09. What is the ratio of the Employment (as % of female employment) of Self-employed in 1995 to that in 1997?
Provide a short and direct response. 1.07. What is the ratio of the Employment (as % of female employment) of Agriculture in 1995 to that in 1998?
Your answer should be compact. 0.91. What is the ratio of the Employment (as % of female employment) in Industry in 1995 to that in 1998?
Your response must be concise. 1.02. What is the ratio of the Employment (as % of female employment) in Self-employed in 1995 to that in 1998?
Ensure brevity in your answer.  1.05. What is the ratio of the Employment (as % of female employment) in Agriculture in 1995 to that in 1999?
Offer a terse response. 1. What is the ratio of the Employment (as % of female employment) of Industry in 1995 to that in 1999?
Your response must be concise. 1.06. What is the ratio of the Employment (as % of female employment) of Services in 1995 to that in 1999?
Make the answer very short. 1.02. What is the ratio of the Employment (as % of female employment) in Self-employed in 1995 to that in 1999?
Give a very brief answer. 1.1. What is the ratio of the Employment (as % of female employment) of Industry in 1995 to that in 2000?
Offer a terse response. 1.08. What is the ratio of the Employment (as % of female employment) in Services in 1995 to that in 2000?
Keep it short and to the point. 1.02. What is the ratio of the Employment (as % of female employment) in Self-employed in 1995 to that in 2000?
Give a very brief answer. 1.05. What is the ratio of the Employment (as % of female employment) in Industry in 1995 to that in 2001?
Provide a short and direct response. 1.14. What is the ratio of the Employment (as % of female employment) in Services in 1995 to that in 2001?
Keep it short and to the point. 1.01. What is the ratio of the Employment (as % of female employment) of Self-employed in 1995 to that in 2001?
Provide a short and direct response. 1.08. What is the ratio of the Employment (as % of female employment) of Industry in 1995 to that in 2002?
Keep it short and to the point. 1.19. What is the ratio of the Employment (as % of female employment) in Services in 1995 to that in 2002?
Your answer should be very brief. 1.04. What is the ratio of the Employment (as % of female employment) of Self-employed in 1995 to that in 2002?
Your response must be concise. 1.2. What is the ratio of the Employment (as % of female employment) of Agriculture in 1996 to that in 1997?
Ensure brevity in your answer.  0.95. What is the ratio of the Employment (as % of female employment) in Industry in 1996 to that in 1997?
Offer a terse response. 1.01. What is the ratio of the Employment (as % of female employment) in Services in 1996 to that in 1997?
Your response must be concise. 0.99. What is the ratio of the Employment (as % of female employment) in Self-employed in 1996 to that in 1997?
Offer a very short reply. 1.08. What is the ratio of the Employment (as % of female employment) in Agriculture in 1996 to that in 1998?
Your answer should be very brief. 0.91. What is the ratio of the Employment (as % of female employment) of Industry in 1996 to that in 1998?
Offer a terse response. 0.95. What is the ratio of the Employment (as % of female employment) in Services in 1996 to that in 1998?
Ensure brevity in your answer.  0.98. What is the ratio of the Employment (as % of female employment) of Self-employed in 1996 to that in 1998?
Offer a very short reply. 1.06. What is the ratio of the Employment (as % of female employment) of Agriculture in 1996 to that in 1999?
Make the answer very short. 1. What is the ratio of the Employment (as % of female employment) in Industry in 1996 to that in 1999?
Offer a very short reply. 0.98. What is the ratio of the Employment (as % of female employment) of Services in 1996 to that in 1999?
Offer a very short reply. 0.98. What is the ratio of the Employment (as % of female employment) in Self-employed in 1996 to that in 1999?
Your answer should be very brief. 1.11. What is the ratio of the Employment (as % of female employment) in Agriculture in 1996 to that in 2000?
Your response must be concise. 1. What is the ratio of the Employment (as % of female employment) of Industry in 1996 to that in 2000?
Your answer should be compact. 1. What is the ratio of the Employment (as % of female employment) of Services in 1996 to that in 2000?
Your answer should be compact. 0.99. What is the ratio of the Employment (as % of female employment) of Self-employed in 1996 to that in 2000?
Provide a short and direct response. 1.06. What is the ratio of the Employment (as % of female employment) of Industry in 1996 to that in 2001?
Your answer should be very brief. 1.06. What is the ratio of the Employment (as % of female employment) in Services in 1996 to that in 2001?
Your answer should be very brief. 0.97. What is the ratio of the Employment (as % of female employment) of Self-employed in 1996 to that in 2001?
Your response must be concise. 1.09. What is the ratio of the Employment (as % of female employment) in Services in 1996 to that in 2002?
Provide a succinct answer. 1. What is the ratio of the Employment (as % of female employment) in Self-employed in 1996 to that in 2002?
Ensure brevity in your answer.  1.21. What is the ratio of the Employment (as % of female employment) of Agriculture in 1997 to that in 1998?
Your answer should be compact. 0.96. What is the ratio of the Employment (as % of female employment) of Industry in 1997 to that in 1998?
Offer a terse response. 0.94. What is the ratio of the Employment (as % of female employment) of Services in 1997 to that in 1998?
Your response must be concise. 1. What is the ratio of the Employment (as % of female employment) of Self-employed in 1997 to that in 1998?
Give a very brief answer. 0.98. What is the ratio of the Employment (as % of female employment) in Agriculture in 1997 to that in 1999?
Provide a succinct answer. 1.05. What is the ratio of the Employment (as % of female employment) of Industry in 1997 to that in 1999?
Your response must be concise. 0.97. What is the ratio of the Employment (as % of female employment) of Self-employed in 1997 to that in 1999?
Ensure brevity in your answer.  1.02. What is the ratio of the Employment (as % of female employment) in Agriculture in 1997 to that in 2000?
Your answer should be compact. 1.05. What is the ratio of the Employment (as % of female employment) in Industry in 1997 to that in 2000?
Offer a very short reply. 0.99. What is the ratio of the Employment (as % of female employment) in Self-employed in 1997 to that in 2000?
Your answer should be compact. 0.98. What is the ratio of the Employment (as % of female employment) of Agriculture in 1997 to that in 2001?
Provide a succinct answer. 0.96. What is the ratio of the Employment (as % of female employment) in Industry in 1997 to that in 2001?
Offer a terse response. 1.05. What is the ratio of the Employment (as % of female employment) of Services in 1997 to that in 2001?
Give a very brief answer. 0.99. What is the ratio of the Employment (as % of female employment) in Self-employed in 1997 to that in 2001?
Your response must be concise. 1.01. What is the ratio of the Employment (as % of female employment) of Agriculture in 1997 to that in 2002?
Your response must be concise. 1.22. What is the ratio of the Employment (as % of female employment) of Industry in 1997 to that in 2002?
Offer a very short reply. 1.09. What is the ratio of the Employment (as % of female employment) of Services in 1997 to that in 2002?
Your answer should be very brief. 1.01. What is the ratio of the Employment (as % of female employment) in Self-employed in 1997 to that in 2002?
Offer a very short reply. 1.12. What is the ratio of the Employment (as % of female employment) in Agriculture in 1998 to that in 1999?
Offer a terse response. 1.1. What is the ratio of the Employment (as % of female employment) of Industry in 1998 to that in 1999?
Provide a short and direct response. 1.03. What is the ratio of the Employment (as % of female employment) of Services in 1998 to that in 1999?
Offer a very short reply. 1. What is the ratio of the Employment (as % of female employment) of Self-employed in 1998 to that in 1999?
Your answer should be compact. 1.04. What is the ratio of the Employment (as % of female employment) of Agriculture in 1998 to that in 2000?
Your response must be concise. 1.1. What is the ratio of the Employment (as % of female employment) in Industry in 1998 to that in 2000?
Ensure brevity in your answer.  1.06. What is the ratio of the Employment (as % of female employment) of Agriculture in 1998 to that in 2001?
Your response must be concise. 1. What is the ratio of the Employment (as % of female employment) in Industry in 1998 to that in 2001?
Provide a succinct answer. 1.12. What is the ratio of the Employment (as % of female employment) in Services in 1998 to that in 2001?
Offer a very short reply. 0.99. What is the ratio of the Employment (as % of female employment) of Self-employed in 1998 to that in 2001?
Your response must be concise. 1.03. What is the ratio of the Employment (as % of female employment) of Agriculture in 1998 to that in 2002?
Make the answer very short. 1.28. What is the ratio of the Employment (as % of female employment) of Industry in 1998 to that in 2002?
Ensure brevity in your answer.  1.16. What is the ratio of the Employment (as % of female employment) in Services in 1998 to that in 2002?
Your answer should be compact. 1.02. What is the ratio of the Employment (as % of female employment) of Self-employed in 1998 to that in 2002?
Offer a very short reply. 1.14. What is the ratio of the Employment (as % of female employment) of Industry in 1999 to that in 2000?
Offer a very short reply. 1.02. What is the ratio of the Employment (as % of female employment) of Services in 1999 to that in 2000?
Provide a short and direct response. 1.01. What is the ratio of the Employment (as % of female employment) of Self-employed in 1999 to that in 2000?
Your response must be concise. 0.96. What is the ratio of the Employment (as % of female employment) of Agriculture in 1999 to that in 2001?
Provide a succinct answer. 0.91. What is the ratio of the Employment (as % of female employment) in Industry in 1999 to that in 2001?
Provide a succinct answer. 1.08. What is the ratio of the Employment (as % of female employment) of Self-employed in 1999 to that in 2001?
Your answer should be compact. 0.99. What is the ratio of the Employment (as % of female employment) of Services in 1999 to that in 2002?
Offer a terse response. 1.02. What is the ratio of the Employment (as % of female employment) of Self-employed in 1999 to that in 2002?
Your response must be concise. 1.09. What is the ratio of the Employment (as % of female employment) of Industry in 2000 to that in 2001?
Make the answer very short. 1.06. What is the ratio of the Employment (as % of female employment) in Services in 2000 to that in 2001?
Offer a terse response. 0.99. What is the ratio of the Employment (as % of female employment) in Self-employed in 2000 to that in 2001?
Your answer should be very brief. 1.03. What is the ratio of the Employment (as % of female employment) in Industry in 2000 to that in 2002?
Your answer should be compact. 1.1. What is the ratio of the Employment (as % of female employment) of Services in 2000 to that in 2002?
Ensure brevity in your answer.  1.02. What is the ratio of the Employment (as % of female employment) in Self-employed in 2000 to that in 2002?
Your response must be concise. 1.14. What is the ratio of the Employment (as % of female employment) of Agriculture in 2001 to that in 2002?
Make the answer very short. 1.28. What is the ratio of the Employment (as % of female employment) of Industry in 2001 to that in 2002?
Your response must be concise. 1.04. What is the ratio of the Employment (as % of female employment) in Services in 2001 to that in 2002?
Your response must be concise. 1.03. What is the ratio of the Employment (as % of female employment) in Self-employed in 2001 to that in 2002?
Your answer should be very brief. 1.1. What is the difference between the highest and the second highest Employment (as % of female employment) of Services?
Offer a very short reply. 1.7. What is the difference between the highest and the lowest Employment (as % of female employment) in Services?
Make the answer very short. 5.1. 